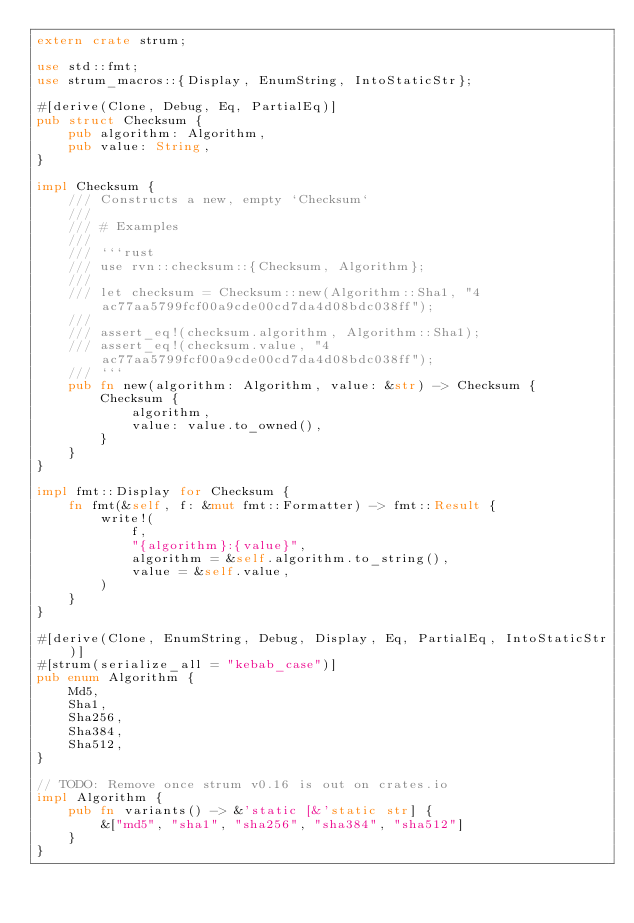<code> <loc_0><loc_0><loc_500><loc_500><_Rust_>extern crate strum;

use std::fmt;
use strum_macros::{Display, EnumString, IntoStaticStr};

#[derive(Clone, Debug, Eq, PartialEq)]
pub struct Checksum {
    pub algorithm: Algorithm,
    pub value: String,
}

impl Checksum {
    /// Constructs a new, empty `Checksum`
    ///
    /// # Examples
    ///
    /// ```rust
    /// use rvn::checksum::{Checksum, Algorithm};
    ///
    /// let checksum = Checksum::new(Algorithm::Sha1, "4ac77aa5799fcf00a9cde00cd7da4d08bdc038ff");
    ///
    /// assert_eq!(checksum.algorithm, Algorithm::Sha1);
    /// assert_eq!(checksum.value, "4ac77aa5799fcf00a9cde00cd7da4d08bdc038ff");
    /// ```
    pub fn new(algorithm: Algorithm, value: &str) -> Checksum {
        Checksum {
            algorithm,
            value: value.to_owned(),
        }
    }
}

impl fmt::Display for Checksum {
    fn fmt(&self, f: &mut fmt::Formatter) -> fmt::Result {
        write!(
            f,
            "{algorithm}:{value}",
            algorithm = &self.algorithm.to_string(),
            value = &self.value,
        )
    }
}

#[derive(Clone, EnumString, Debug, Display, Eq, PartialEq, IntoStaticStr)]
#[strum(serialize_all = "kebab_case")]
pub enum Algorithm {
    Md5,
    Sha1,
    Sha256,
    Sha384,
    Sha512,
}

// TODO: Remove once strum v0.16 is out on crates.io
impl Algorithm {
    pub fn variants() -> &'static [&'static str] {
        &["md5", "sha1", "sha256", "sha384", "sha512"]
    }
}
</code> 